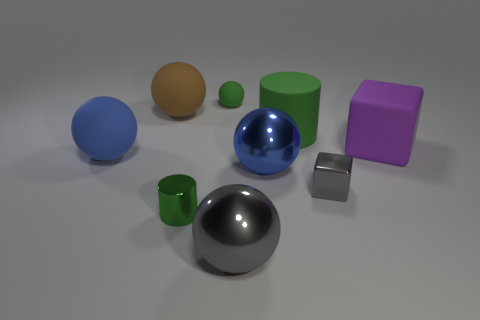Subtract all green rubber balls. How many balls are left? 4 Subtract all green cubes. How many blue balls are left? 2 Add 1 tiny brown matte blocks. How many objects exist? 10 Subtract all brown balls. How many balls are left? 4 Subtract 2 spheres. How many spheres are left? 3 Subtract all small gray cubes. Subtract all small objects. How many objects are left? 5 Add 3 purple things. How many purple things are left? 4 Add 6 purple blocks. How many purple blocks exist? 7 Subtract 0 cyan blocks. How many objects are left? 9 Subtract all cylinders. How many objects are left? 7 